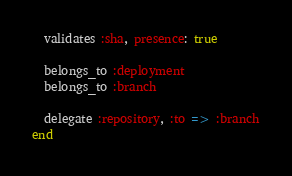Convert code to text. <code><loc_0><loc_0><loc_500><loc_500><_Ruby_>  validates :sha, presence: true

  belongs_to :deployment
  belongs_to :branch

  delegate :repository, :to => :branch
end
</code> 